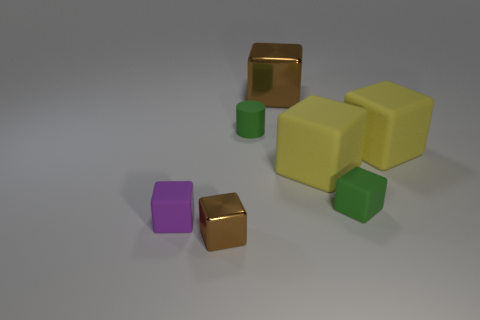Subtract all brown blocks. How many blocks are left? 4 Subtract all green cubes. How many cubes are left? 5 Subtract all blue cubes. Subtract all cyan balls. How many cubes are left? 6 Add 2 purple rubber blocks. How many objects exist? 9 Subtract all cubes. How many objects are left? 1 Subtract all cylinders. Subtract all large brown matte things. How many objects are left? 6 Add 4 matte cubes. How many matte cubes are left? 8 Add 7 large yellow cubes. How many large yellow cubes exist? 9 Subtract 0 yellow spheres. How many objects are left? 7 